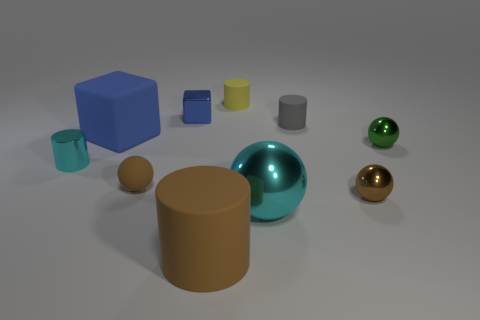There is a metallic ball that is behind the small cylinder on the left side of the rubber cylinder that is in front of the tiny green metallic object; what size is it?
Offer a very short reply. Small. There is a thing that is both to the left of the yellow rubber cylinder and behind the gray object; what is its size?
Your response must be concise. Small. Does the small ball that is on the left side of the big cyan object have the same color as the rubber cylinder that is in front of the small gray cylinder?
Provide a short and direct response. Yes. What number of cyan shiny objects are behind the brown metallic ball?
Provide a short and direct response. 1. Is there a small cyan shiny thing that is behind the small cylinder that is left of the large rubber object in front of the metal cylinder?
Offer a terse response. No. How many brown shiny spheres have the same size as the metallic cube?
Your answer should be compact. 1. There is a brown sphere right of the cyan object that is right of the tiny shiny cylinder; what is it made of?
Offer a terse response. Metal. The tiny object that is behind the blue block right of the small ball that is to the left of the gray cylinder is what shape?
Provide a succinct answer. Cylinder. Does the tiny matte thing that is behind the tiny block have the same shape as the large matte object that is in front of the shiny cylinder?
Ensure brevity in your answer.  Yes. The small green thing that is the same material as the tiny cube is what shape?
Keep it short and to the point. Sphere. 